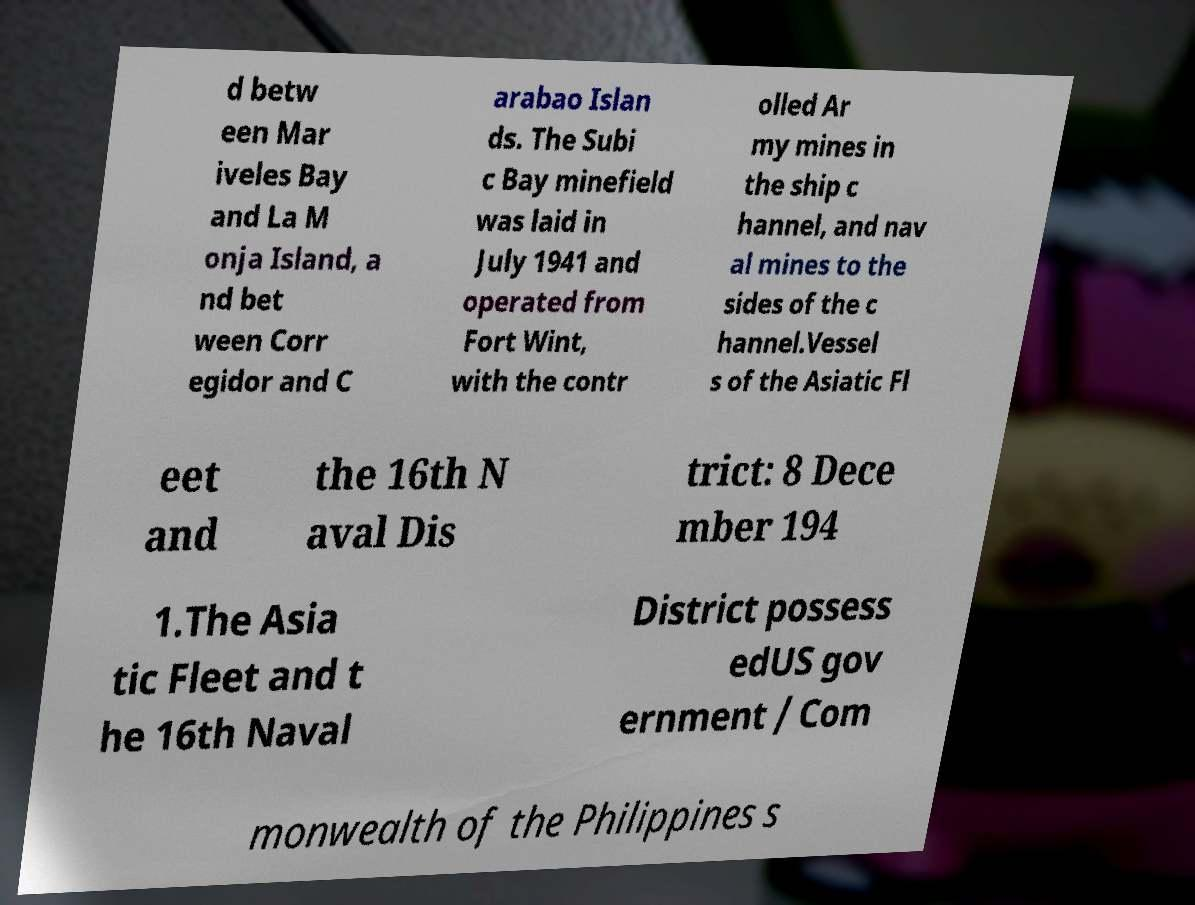Please identify and transcribe the text found in this image. d betw een Mar iveles Bay and La M onja Island, a nd bet ween Corr egidor and C arabao Islan ds. The Subi c Bay minefield was laid in July 1941 and operated from Fort Wint, with the contr olled Ar my mines in the ship c hannel, and nav al mines to the sides of the c hannel.Vessel s of the Asiatic Fl eet and the 16th N aval Dis trict: 8 Dece mber 194 1.The Asia tic Fleet and t he 16th Naval District possess edUS gov ernment / Com monwealth of the Philippines s 